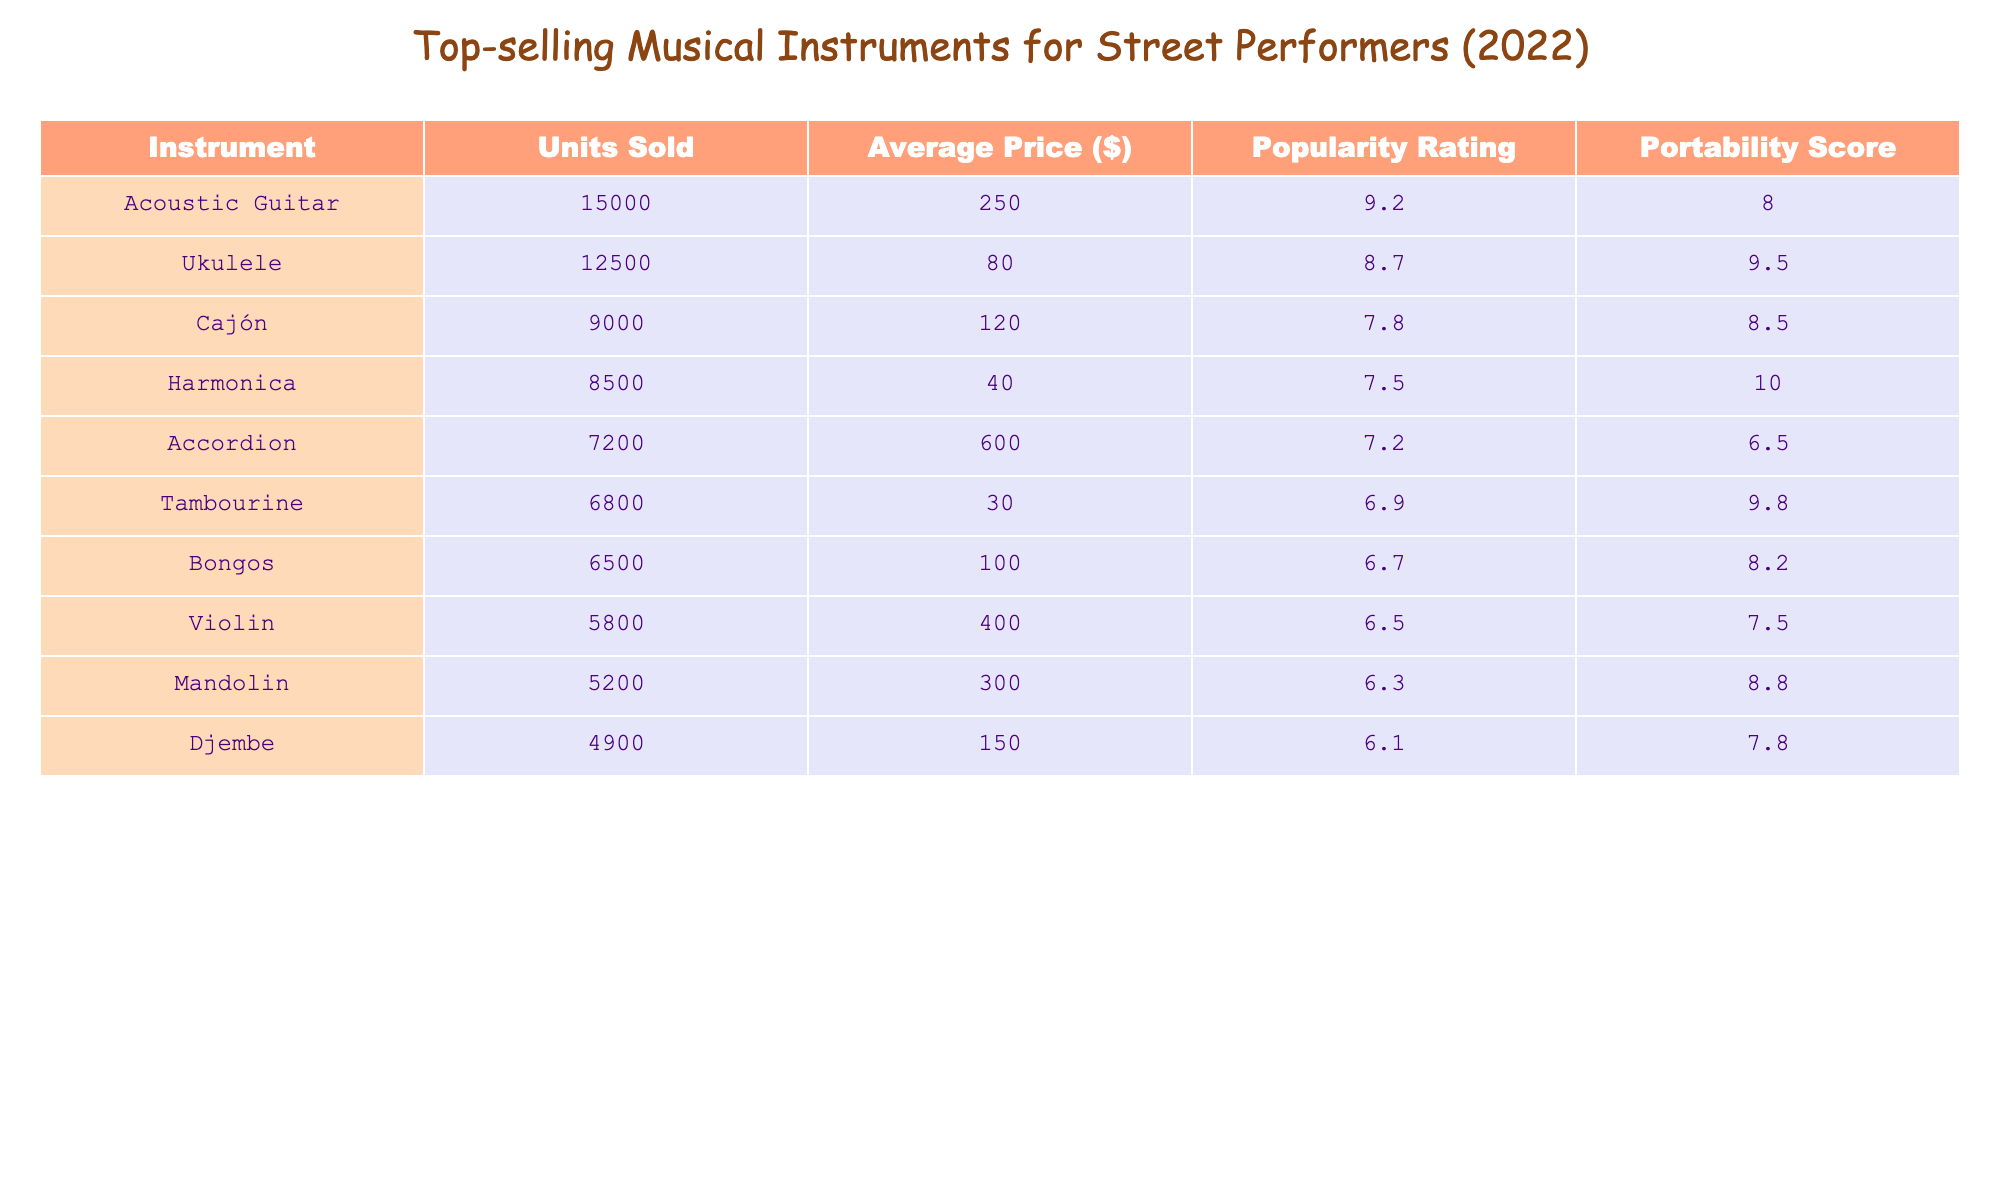What is the average price of the Cajón? The average price of the Cajón is listed as $120, which directly corresponds to the value in the table under the "Average Price ($)" column for Cajón.
Answer: $120 Which instrument has the highest popularity rating? The instrument with the highest popularity rating is the Acoustic Guitar, with a rating of 9.2 as noted in the "Popularity Rating" column.
Answer: Acoustic Guitar How many units of Ukuleles were sold compared to Harmonicas? The Ukulele units sold are 12,500 and Harmonica units sold are 8,500. The difference is calculated as 12,500 - 8,500 = 4,000.
Answer: 4,000 Is the average price of a Tambourine less than $50? The average price of a Tambourine is $30, which is indeed less than $50, reflecting a true statement based on the information from the table.
Answer: Yes What is the total number of units sold for all instruments listed? The total units sold is calculated by summing each instrument's units: 15,000 + 12,500 + 9,000 + 8,500 + 7,200 + 6,800 + 6,500 + 5,800 + 5,200 + 4,900 = 81,400.
Answer: 81,400 Which instrument has the lowest portability score, and what is that score? The instrument with the lowest portability score is the Accordion, which has a score of 6.5 as indicated in the "Portability Score" column.
Answer: Accordion, 6.5 What is the average popularity rating for all instruments combined? We must sum all popularity ratings: 9.2 + 8.7 + 7.8 + 7.5 + 7.2 + 6.9 + 6.7 + 6.5 + 6.3 + 6.1 = 78.0, and then divide by the number of instruments (10) to find the average: 78.0 / 10 = 7.8.
Answer: 7.8 Which instrument has a higher average price, the Violin or the Mandolin? The Violin’s average price is $400 while the Mandolin’s average price is $300. Comparing the two shows that the Violin has the higher price.
Answer: Violin How many more units of Bongos were sold than Djembe? Bongos sold 6,500 units while Djembe sold 4,900 units. The difference is calculated by subtracting the Djembe units from Bongos units: 6,500 - 4,900 = 1,600.
Answer: 1,600 Is the average price of an Accordion higher than $500? The average price of an Accordion is $600, which is indeed higher than $500, making this statement true according to the values in the table.
Answer: Yes 